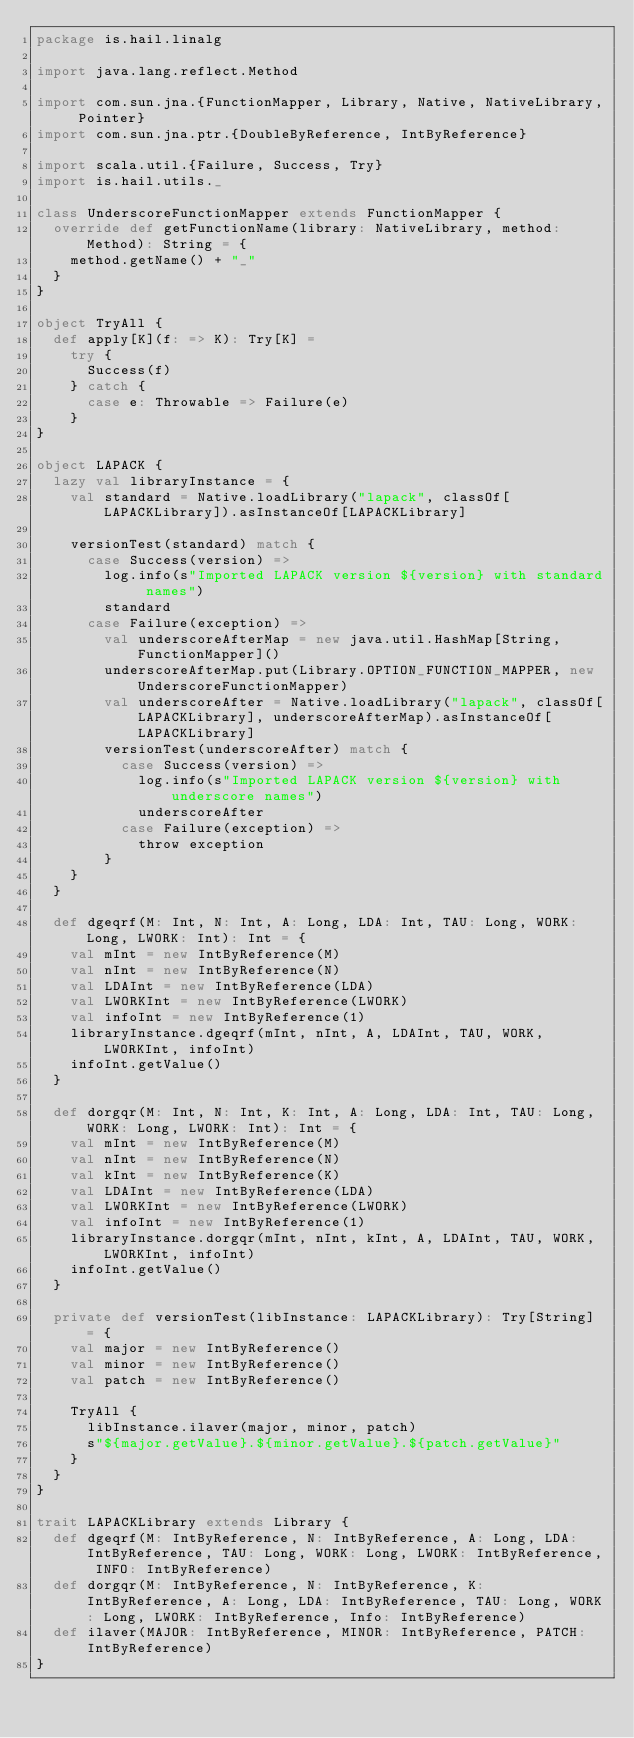Convert code to text. <code><loc_0><loc_0><loc_500><loc_500><_Scala_>package is.hail.linalg

import java.lang.reflect.Method

import com.sun.jna.{FunctionMapper, Library, Native, NativeLibrary, Pointer}
import com.sun.jna.ptr.{DoubleByReference, IntByReference}

import scala.util.{Failure, Success, Try}
import is.hail.utils._

class UnderscoreFunctionMapper extends FunctionMapper {
  override def getFunctionName(library: NativeLibrary, method: Method): String = {
    method.getName() + "_"
  }
}

object TryAll {
  def apply[K](f: => K): Try[K] =
    try {
      Success(f)
    } catch {
      case e: Throwable => Failure(e)
    }
}

object LAPACK {
  lazy val libraryInstance = {
    val standard = Native.loadLibrary("lapack", classOf[LAPACKLibrary]).asInstanceOf[LAPACKLibrary]

    versionTest(standard) match {
      case Success(version) =>
        log.info(s"Imported LAPACK version ${version} with standard names")
        standard
      case Failure(exception) =>
        val underscoreAfterMap = new java.util.HashMap[String, FunctionMapper]()
        underscoreAfterMap.put(Library.OPTION_FUNCTION_MAPPER, new UnderscoreFunctionMapper)
        val underscoreAfter = Native.loadLibrary("lapack", classOf[LAPACKLibrary], underscoreAfterMap).asInstanceOf[LAPACKLibrary]
        versionTest(underscoreAfter) match {
          case Success(version) =>
            log.info(s"Imported LAPACK version ${version} with underscore names")
            underscoreAfter
          case Failure(exception) =>
            throw exception
        }
    }
  }

  def dgeqrf(M: Int, N: Int, A: Long, LDA: Int, TAU: Long, WORK: Long, LWORK: Int): Int = {
    val mInt = new IntByReference(M)
    val nInt = new IntByReference(N)
    val LDAInt = new IntByReference(LDA)
    val LWORKInt = new IntByReference(LWORK)
    val infoInt = new IntByReference(1)
    libraryInstance.dgeqrf(mInt, nInt, A, LDAInt, TAU, WORK, LWORKInt, infoInt)
    infoInt.getValue()
  }

  def dorgqr(M: Int, N: Int, K: Int, A: Long, LDA: Int, TAU: Long, WORK: Long, LWORK: Int): Int = {
    val mInt = new IntByReference(M)
    val nInt = new IntByReference(N)
    val kInt = new IntByReference(K)
    val LDAInt = new IntByReference(LDA)
    val LWORKInt = new IntByReference(LWORK)
    val infoInt = new IntByReference(1)
    libraryInstance.dorgqr(mInt, nInt, kInt, A, LDAInt, TAU, WORK, LWORKInt, infoInt)
    infoInt.getValue()
  }

  private def versionTest(libInstance: LAPACKLibrary): Try[String] = {
    val major = new IntByReference()
    val minor = new IntByReference()
    val patch = new IntByReference()

    TryAll {
      libInstance.ilaver(major, minor, patch)
      s"${major.getValue}.${minor.getValue}.${patch.getValue}"
    }
  }
}

trait LAPACKLibrary extends Library {
  def dgeqrf(M: IntByReference, N: IntByReference, A: Long, LDA: IntByReference, TAU: Long, WORK: Long, LWORK: IntByReference, INFO: IntByReference)
  def dorgqr(M: IntByReference, N: IntByReference, K: IntByReference, A: Long, LDA: IntByReference, TAU: Long, WORK: Long, LWORK: IntByReference, Info: IntByReference)
  def ilaver(MAJOR: IntByReference, MINOR: IntByReference, PATCH: IntByReference)
}</code> 